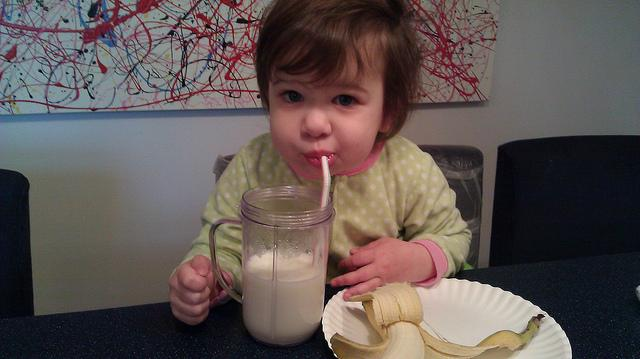What animal is known for eating the item on the plate? Please explain your reasoning. monkey. If you see a monkey on television there is a good chance you will also see a banana. 